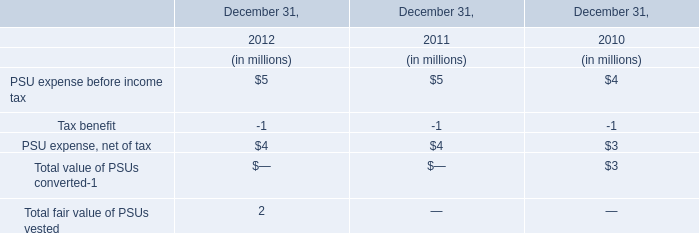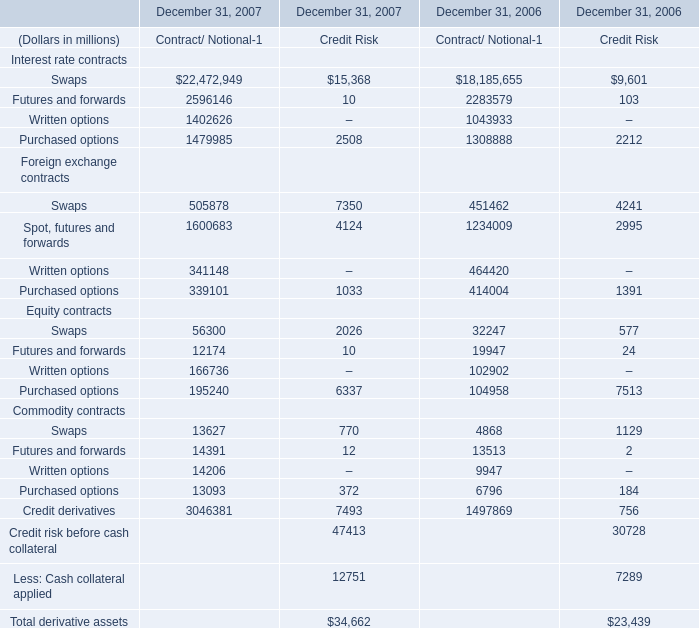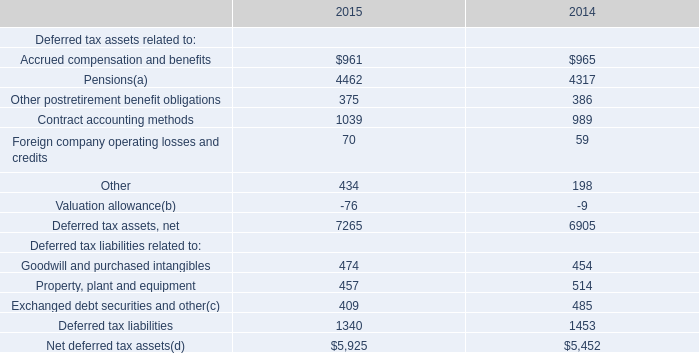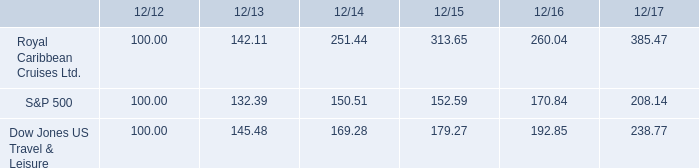What's the growth rate of Total derivative assets in 2007? 
Computations: ((34662 - 23439) / 34662)
Answer: 0.32378. 